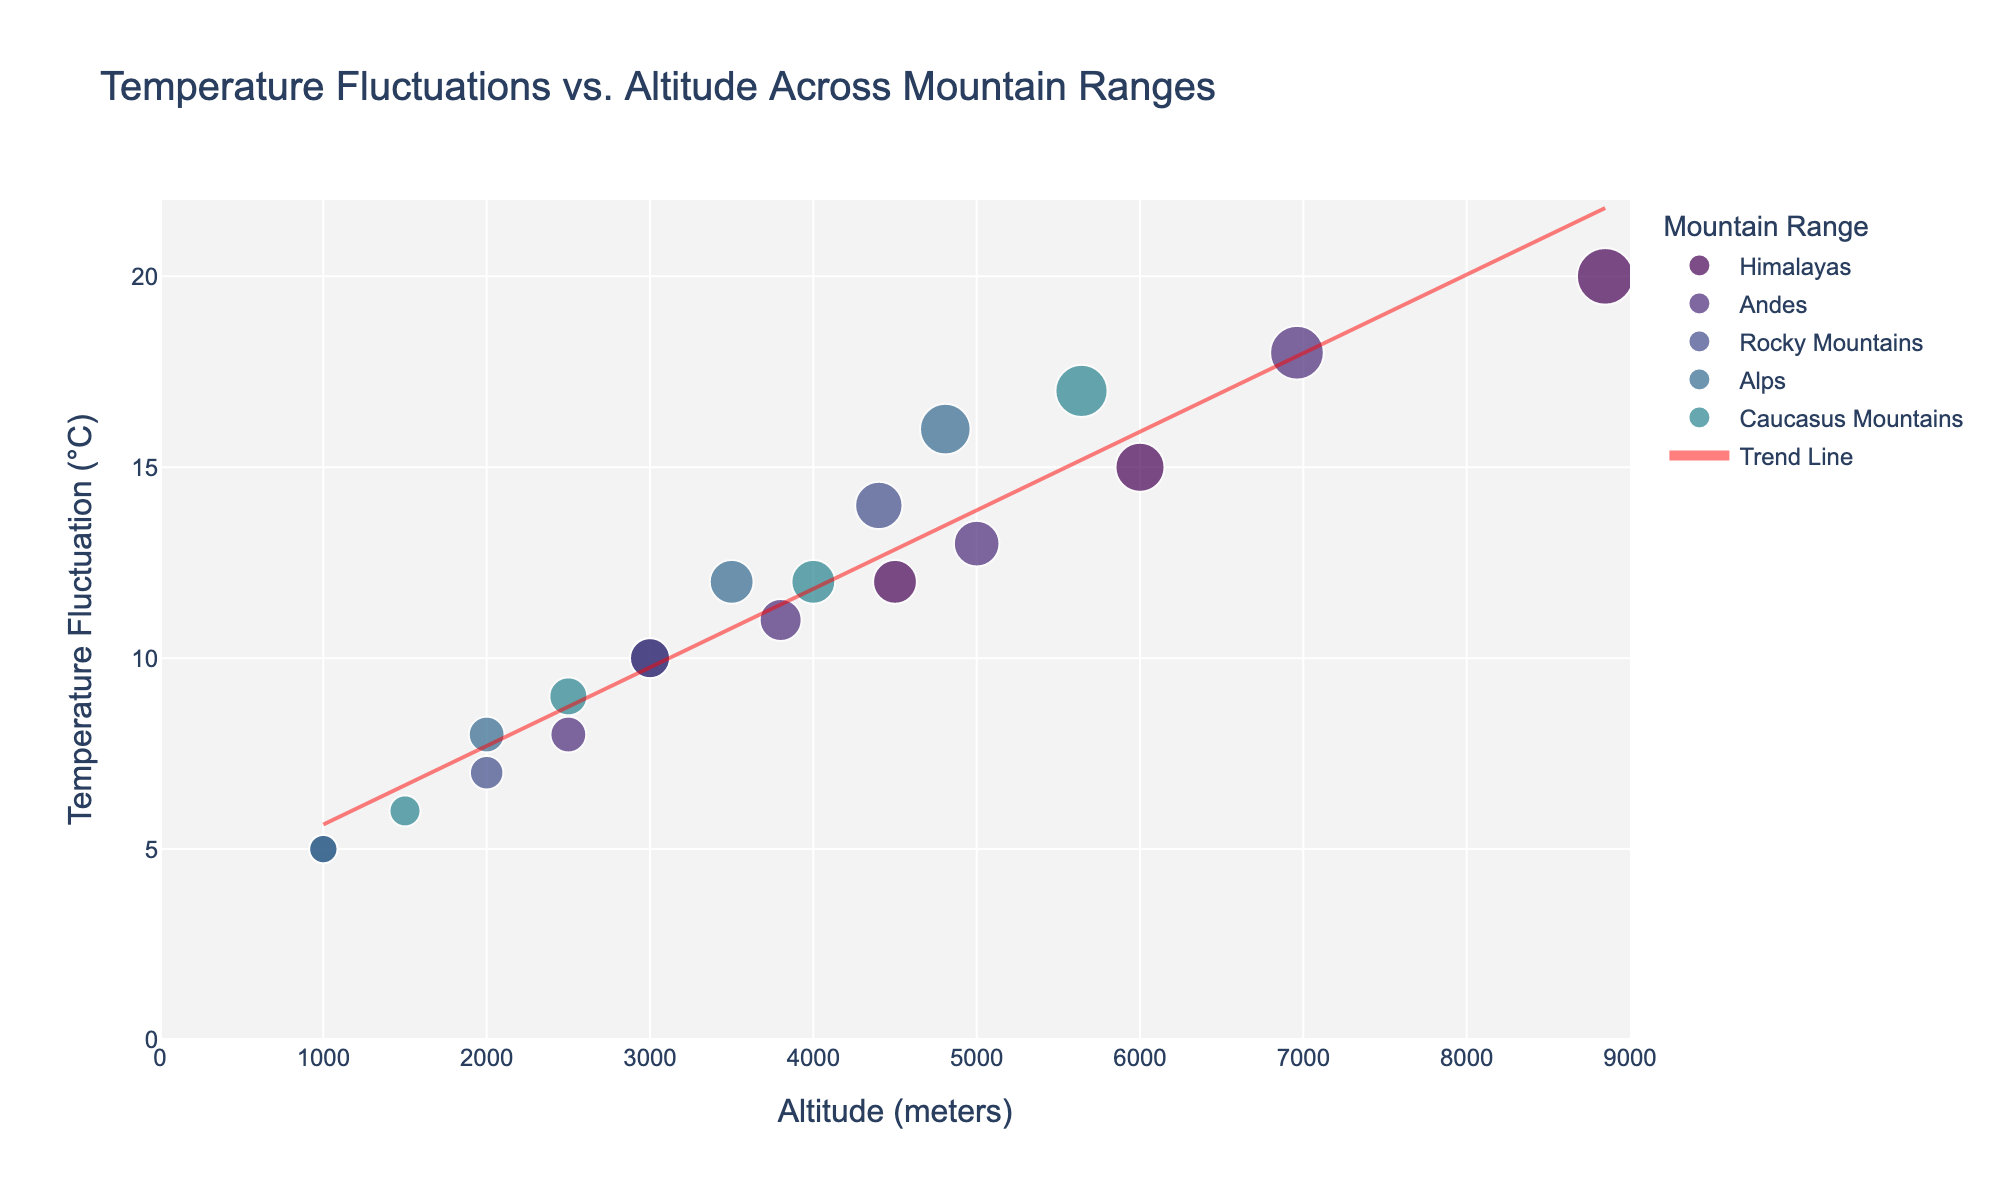What's the title of the figure? The title is usually found at the top of the figure. In this plot, the title specifies the main focus of the visualization, which is "Temperature Fluctuations vs. Altitude Across Mountain Ranges".
Answer: Temperature Fluctuations vs. Altitude Across Mountain Ranges How many mountain ranges are represented in the figure? Count the unique labels shown in the legend or distinct points categorized by color. This figure represents five mountain ranges: Himalayas, Andes, Rocky Mountains, Alps, Caucasus Mountains.
Answer: Five At what altitude do the Alps have a temperature fluctuation of 12°C? Locate the color corresponding to the Alps in the legend, then track the scatter points for the Alps to find the one with a y-value of 12°C. The altitude for the Alps at this temperature is 3500 meters.
Answer: 3500 meters Which mountain range has the highest altitude point, and what is its corresponding temperature fluctuation? Find the point that reaches the highest x-value (Altitude axis) and check its color. The highest point is part of the Himalayas with an altitude of 8848 meters and a temperature fluctuation of 20°C.
Answer: Himalayas, 20°C What is the overall trend in temperature fluctuations as altitude increases? Observe the trend line added to the scatter plot which represents the general tendency of the data. The trend line slopes downward, indicating that as altitude increases, temperature fluctuation generally decreases.
Answer: Decreases Compare the temperature fluctuations of the Andes and Rocky Mountains at an altitude of 3000 meters. Identify the points at 3000 meters altitude for both the Andes (using its distinct color) and Rocky Mountains. The Andes have a temperature fluctuation of 13°C, while the Rocky Mountains have 10°C at this altitude.
Answer: Andes: 13°C, Rocky Mountains: 10°C What is the altitude range covered by the plot? Check the x-axis range from the lowest to the highest value. According to the customization settings, the altitude range is from 0 to 9000 meters.
Answer: 0 to 9000 meters What's the average temperature fluctuation recorded for the Himalayas? Identify the temperature fluctuations for the Himalayas (20, 15, 12, 10°C) and compute their average. (20 + 15 + 12 + 10)/4 = 57/4 = 14.25
Answer: 14.25°C Which mountain range has the least maximum temperature fluctuation, and what is that fluctuation? Look at the highest y-values for each mountain range and identify the smallest one. The Rocky Mountains have the least maximum temperature fluctuation of 14°C.
Answer: Rocky Mountains, 14°C How does the temperature fluctuation in the Caucasus Mountains change as altitude increases from 1500 meters to 5642 meters? Locate the points for Caucasus Mountains at 1500 meters and 5642 meters and note their y-values (6°C and 17°C respectively). The temperature fluctuation increases from 6°C to 17°C as altitude increases.
Answer: Increases 